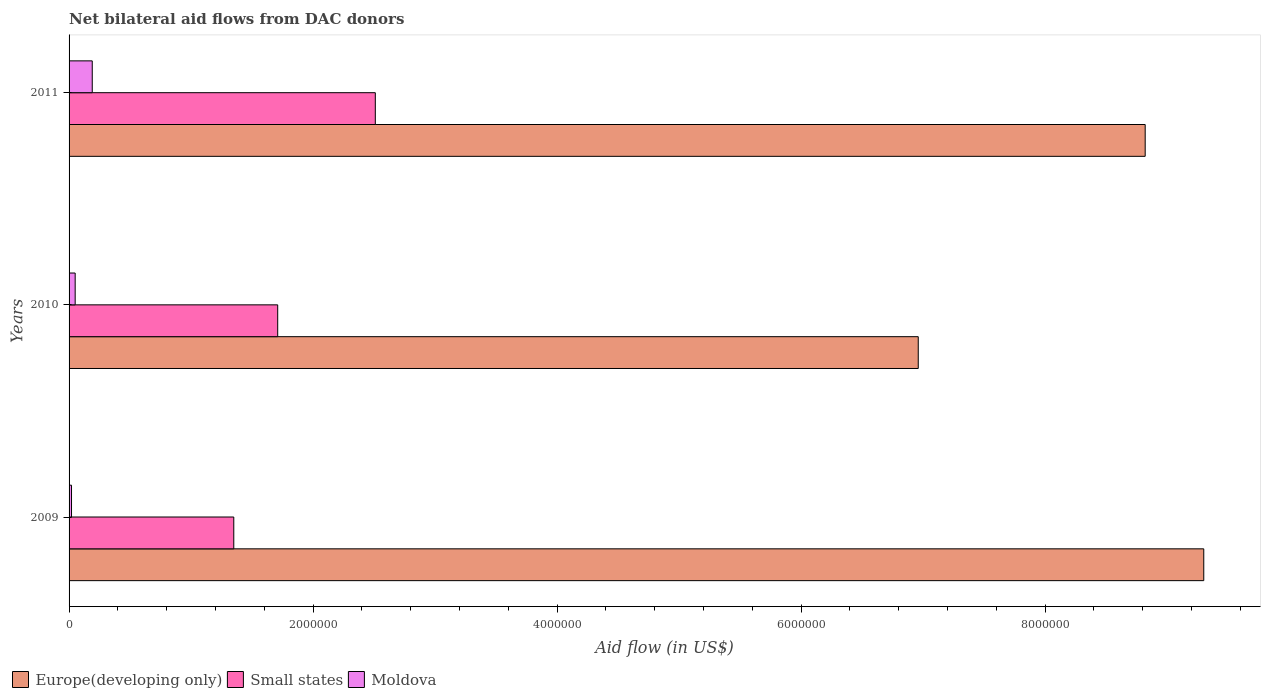How many different coloured bars are there?
Ensure brevity in your answer.  3. How many groups of bars are there?
Provide a short and direct response. 3. Are the number of bars on each tick of the Y-axis equal?
Provide a short and direct response. Yes. How many bars are there on the 2nd tick from the bottom?
Your answer should be very brief. 3. What is the label of the 2nd group of bars from the top?
Provide a short and direct response. 2010. In how many cases, is the number of bars for a given year not equal to the number of legend labels?
Offer a terse response. 0. What is the net bilateral aid flow in Small states in 2011?
Your answer should be compact. 2.51e+06. In which year was the net bilateral aid flow in Small states maximum?
Offer a very short reply. 2011. In which year was the net bilateral aid flow in Europe(developing only) minimum?
Your answer should be very brief. 2010. What is the difference between the net bilateral aid flow in Europe(developing only) in 2010 and that in 2011?
Give a very brief answer. -1.86e+06. What is the difference between the net bilateral aid flow in Europe(developing only) in 2010 and the net bilateral aid flow in Moldova in 2011?
Offer a terse response. 6.77e+06. What is the average net bilateral aid flow in Moldova per year?
Provide a short and direct response. 8.67e+04. In the year 2010, what is the difference between the net bilateral aid flow in Moldova and net bilateral aid flow in Europe(developing only)?
Your answer should be very brief. -6.91e+06. What is the ratio of the net bilateral aid flow in Moldova in 2009 to that in 2010?
Provide a short and direct response. 0.4. Is the difference between the net bilateral aid flow in Moldova in 2009 and 2011 greater than the difference between the net bilateral aid flow in Europe(developing only) in 2009 and 2011?
Keep it short and to the point. No. What is the difference between the highest and the second highest net bilateral aid flow in Small states?
Your answer should be compact. 8.00e+05. What is the difference between the highest and the lowest net bilateral aid flow in Small states?
Provide a succinct answer. 1.16e+06. Is the sum of the net bilateral aid flow in Small states in 2009 and 2010 greater than the maximum net bilateral aid flow in Europe(developing only) across all years?
Keep it short and to the point. No. What does the 2nd bar from the top in 2010 represents?
Offer a very short reply. Small states. What does the 3rd bar from the bottom in 2009 represents?
Your answer should be compact. Moldova. Are all the bars in the graph horizontal?
Your response must be concise. Yes. What is the difference between two consecutive major ticks on the X-axis?
Provide a succinct answer. 2.00e+06. Are the values on the major ticks of X-axis written in scientific E-notation?
Your answer should be compact. No. Does the graph contain grids?
Your answer should be very brief. No. How are the legend labels stacked?
Keep it short and to the point. Horizontal. What is the title of the graph?
Your response must be concise. Net bilateral aid flows from DAC donors. What is the label or title of the X-axis?
Offer a very short reply. Aid flow (in US$). What is the Aid flow (in US$) in Europe(developing only) in 2009?
Offer a terse response. 9.30e+06. What is the Aid flow (in US$) of Small states in 2009?
Ensure brevity in your answer.  1.35e+06. What is the Aid flow (in US$) in Moldova in 2009?
Keep it short and to the point. 2.00e+04. What is the Aid flow (in US$) of Europe(developing only) in 2010?
Make the answer very short. 6.96e+06. What is the Aid flow (in US$) of Small states in 2010?
Your response must be concise. 1.71e+06. What is the Aid flow (in US$) in Europe(developing only) in 2011?
Your answer should be very brief. 8.82e+06. What is the Aid flow (in US$) in Small states in 2011?
Your answer should be compact. 2.51e+06. Across all years, what is the maximum Aid flow (in US$) in Europe(developing only)?
Your answer should be compact. 9.30e+06. Across all years, what is the maximum Aid flow (in US$) of Small states?
Your answer should be very brief. 2.51e+06. Across all years, what is the maximum Aid flow (in US$) in Moldova?
Your answer should be compact. 1.90e+05. Across all years, what is the minimum Aid flow (in US$) in Europe(developing only)?
Provide a succinct answer. 6.96e+06. Across all years, what is the minimum Aid flow (in US$) in Small states?
Ensure brevity in your answer.  1.35e+06. What is the total Aid flow (in US$) in Europe(developing only) in the graph?
Your answer should be compact. 2.51e+07. What is the total Aid flow (in US$) of Small states in the graph?
Offer a very short reply. 5.57e+06. What is the difference between the Aid flow (in US$) of Europe(developing only) in 2009 and that in 2010?
Give a very brief answer. 2.34e+06. What is the difference between the Aid flow (in US$) in Small states in 2009 and that in 2010?
Your response must be concise. -3.60e+05. What is the difference between the Aid flow (in US$) of Moldova in 2009 and that in 2010?
Make the answer very short. -3.00e+04. What is the difference between the Aid flow (in US$) in Small states in 2009 and that in 2011?
Give a very brief answer. -1.16e+06. What is the difference between the Aid flow (in US$) of Moldova in 2009 and that in 2011?
Provide a short and direct response. -1.70e+05. What is the difference between the Aid flow (in US$) of Europe(developing only) in 2010 and that in 2011?
Provide a short and direct response. -1.86e+06. What is the difference between the Aid flow (in US$) of Small states in 2010 and that in 2011?
Provide a succinct answer. -8.00e+05. What is the difference between the Aid flow (in US$) of Europe(developing only) in 2009 and the Aid flow (in US$) of Small states in 2010?
Your response must be concise. 7.59e+06. What is the difference between the Aid flow (in US$) in Europe(developing only) in 2009 and the Aid flow (in US$) in Moldova in 2010?
Provide a short and direct response. 9.25e+06. What is the difference between the Aid flow (in US$) in Small states in 2009 and the Aid flow (in US$) in Moldova in 2010?
Ensure brevity in your answer.  1.30e+06. What is the difference between the Aid flow (in US$) of Europe(developing only) in 2009 and the Aid flow (in US$) of Small states in 2011?
Provide a short and direct response. 6.79e+06. What is the difference between the Aid flow (in US$) of Europe(developing only) in 2009 and the Aid flow (in US$) of Moldova in 2011?
Make the answer very short. 9.11e+06. What is the difference between the Aid flow (in US$) in Small states in 2009 and the Aid flow (in US$) in Moldova in 2011?
Offer a terse response. 1.16e+06. What is the difference between the Aid flow (in US$) in Europe(developing only) in 2010 and the Aid flow (in US$) in Small states in 2011?
Provide a short and direct response. 4.45e+06. What is the difference between the Aid flow (in US$) of Europe(developing only) in 2010 and the Aid flow (in US$) of Moldova in 2011?
Provide a succinct answer. 6.77e+06. What is the difference between the Aid flow (in US$) in Small states in 2010 and the Aid flow (in US$) in Moldova in 2011?
Give a very brief answer. 1.52e+06. What is the average Aid flow (in US$) of Europe(developing only) per year?
Make the answer very short. 8.36e+06. What is the average Aid flow (in US$) of Small states per year?
Your answer should be very brief. 1.86e+06. What is the average Aid flow (in US$) in Moldova per year?
Give a very brief answer. 8.67e+04. In the year 2009, what is the difference between the Aid flow (in US$) in Europe(developing only) and Aid flow (in US$) in Small states?
Provide a short and direct response. 7.95e+06. In the year 2009, what is the difference between the Aid flow (in US$) in Europe(developing only) and Aid flow (in US$) in Moldova?
Make the answer very short. 9.28e+06. In the year 2009, what is the difference between the Aid flow (in US$) of Small states and Aid flow (in US$) of Moldova?
Your answer should be very brief. 1.33e+06. In the year 2010, what is the difference between the Aid flow (in US$) of Europe(developing only) and Aid flow (in US$) of Small states?
Give a very brief answer. 5.25e+06. In the year 2010, what is the difference between the Aid flow (in US$) in Europe(developing only) and Aid flow (in US$) in Moldova?
Give a very brief answer. 6.91e+06. In the year 2010, what is the difference between the Aid flow (in US$) in Small states and Aid flow (in US$) in Moldova?
Offer a very short reply. 1.66e+06. In the year 2011, what is the difference between the Aid flow (in US$) of Europe(developing only) and Aid flow (in US$) of Small states?
Offer a terse response. 6.31e+06. In the year 2011, what is the difference between the Aid flow (in US$) of Europe(developing only) and Aid flow (in US$) of Moldova?
Your response must be concise. 8.63e+06. In the year 2011, what is the difference between the Aid flow (in US$) in Small states and Aid flow (in US$) in Moldova?
Offer a terse response. 2.32e+06. What is the ratio of the Aid flow (in US$) of Europe(developing only) in 2009 to that in 2010?
Keep it short and to the point. 1.34. What is the ratio of the Aid flow (in US$) in Small states in 2009 to that in 2010?
Your answer should be very brief. 0.79. What is the ratio of the Aid flow (in US$) of Europe(developing only) in 2009 to that in 2011?
Make the answer very short. 1.05. What is the ratio of the Aid flow (in US$) of Small states in 2009 to that in 2011?
Your answer should be very brief. 0.54. What is the ratio of the Aid flow (in US$) in Moldova in 2009 to that in 2011?
Give a very brief answer. 0.11. What is the ratio of the Aid flow (in US$) in Europe(developing only) in 2010 to that in 2011?
Provide a short and direct response. 0.79. What is the ratio of the Aid flow (in US$) in Small states in 2010 to that in 2011?
Offer a terse response. 0.68. What is the ratio of the Aid flow (in US$) in Moldova in 2010 to that in 2011?
Ensure brevity in your answer.  0.26. What is the difference between the highest and the second highest Aid flow (in US$) in Europe(developing only)?
Keep it short and to the point. 4.80e+05. What is the difference between the highest and the second highest Aid flow (in US$) in Small states?
Offer a very short reply. 8.00e+05. What is the difference between the highest and the second highest Aid flow (in US$) of Moldova?
Offer a very short reply. 1.40e+05. What is the difference between the highest and the lowest Aid flow (in US$) in Europe(developing only)?
Keep it short and to the point. 2.34e+06. What is the difference between the highest and the lowest Aid flow (in US$) of Small states?
Give a very brief answer. 1.16e+06. What is the difference between the highest and the lowest Aid flow (in US$) in Moldova?
Make the answer very short. 1.70e+05. 